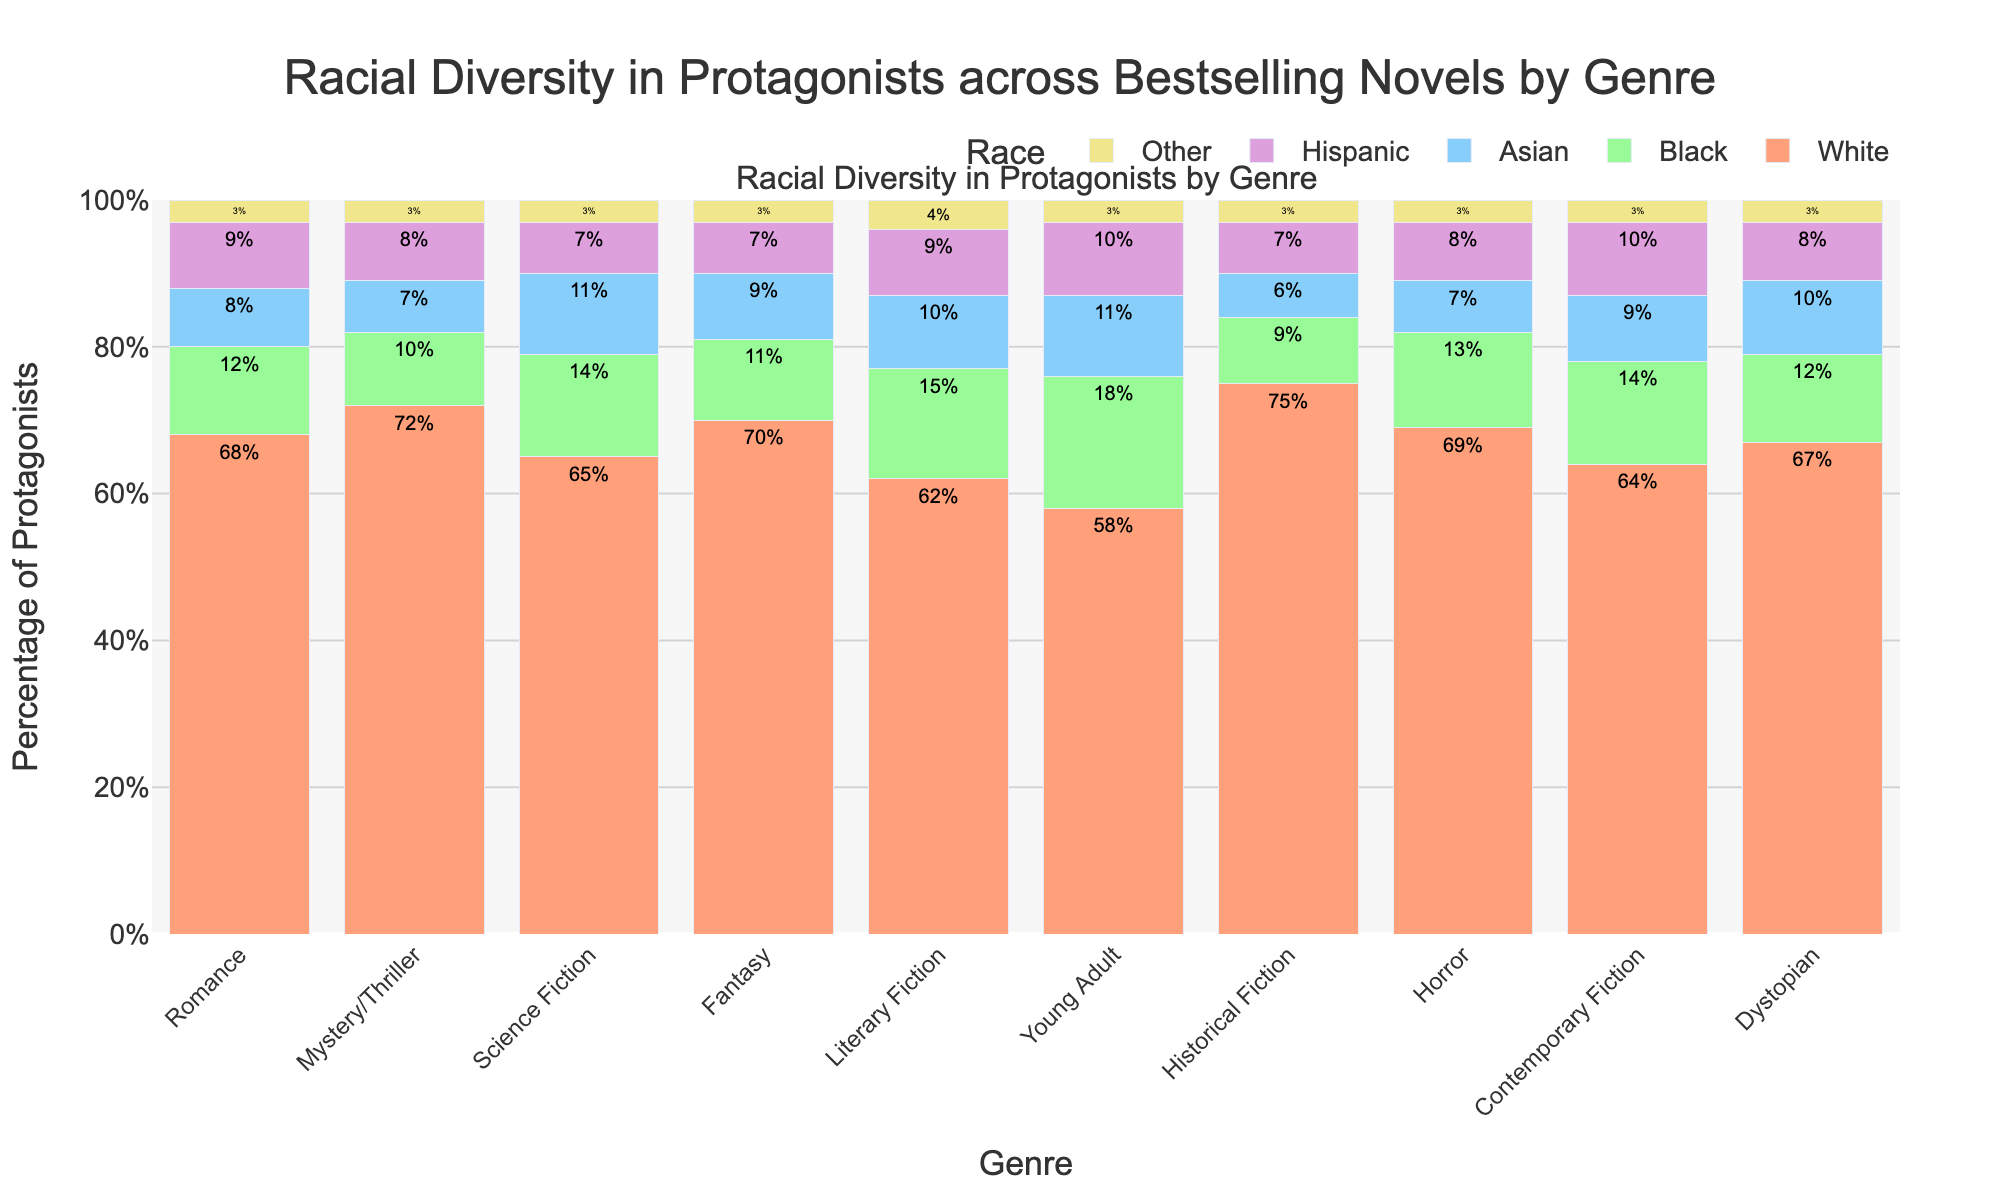Which genre has the highest percentage of White protagonists? By observing the heights of the bars for White protagonists across all genres, Historical Fiction has the tallest bar, indicating it has the highest percentage of White protagonists.
Answer: Historical Fiction Which genre has the lowest percentage of Asian protagonists? By comparing the bar heights for Asian protagonists, Historical Fiction has the shortest bar, indicating it has the lowest percentage of Asian protagonists.
Answer: Historical Fiction What is the combined percentage of Black and Hispanic protagonists in Science Fiction? Adding the percentages of Black and Hispanic protagonists in Science Fiction, 14% + 7% gives a total of 21%.
Answer: 21% Are there any genres where the percentage of White protagonists is less than 60%? Checking the bar lengths for White protagonists, Young Adult is the only genre where the percentage is below 60%, specifically at 58%.
Answer: Yes, Young Adult Which genre shows the most racial diversity among protagonists? By comparing the variety and balance of bar heights across all races within each genre, Contemporary Fiction and Young Adult have the most balanced distribution and therefore the most racial diversity.
Answer: Contemporary Fiction and Young Adult In which genres do Black protagonists exceed 15%? By observing the heights of the bars for Black protagonists, only Literary Fiction and Young Adult have bars exceeding 15%.
Answer: Literary Fiction and Young Adult How does the percentage of Hispanic protagonists in Romance compare to that in Mystery/Thriller? Comparing the heights of the bars for Hispanic protagonists, Romance has a slightly higher percentage (9%) compared to Mystery/Thriller (8%).
Answer: Romance is higher What is the difference in the combined percentages of Asian and Other protagonists between Fantasy and Horror? Calculating the combined percentage for Asian and Other protagonists in Fantasy (9% + 3% = 12%) and Horror (7% + 3% = 10%), the difference is 2%.
Answer: 2% Which genre has the second highest percentage of Black protagonists? By examining the bar heights for Black protagonists, Science Fiction has the second highest percentage at 14%, following Young Adult at 18%.
Answer: Science Fiction 